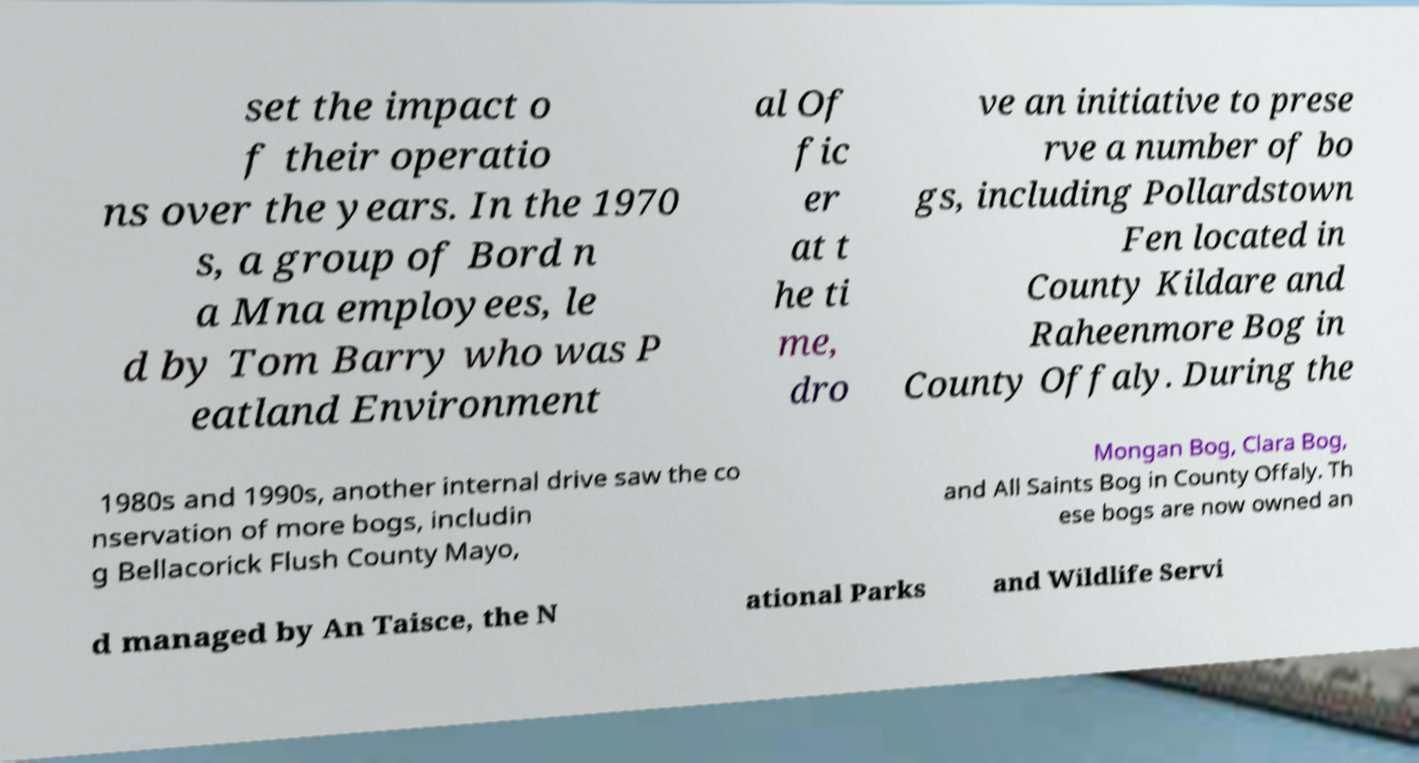Could you assist in decoding the text presented in this image and type it out clearly? set the impact o f their operatio ns over the years. In the 1970 s, a group of Bord n a Mna employees, le d by Tom Barry who was P eatland Environment al Of fic er at t he ti me, dro ve an initiative to prese rve a number of bo gs, including Pollardstown Fen located in County Kildare and Raheenmore Bog in County Offaly. During the 1980s and 1990s, another internal drive saw the co nservation of more bogs, includin g Bellacorick Flush County Mayo, Mongan Bog, Clara Bog, and All Saints Bog in County Offaly. Th ese bogs are now owned an d managed by An Taisce, the N ational Parks and Wildlife Servi 